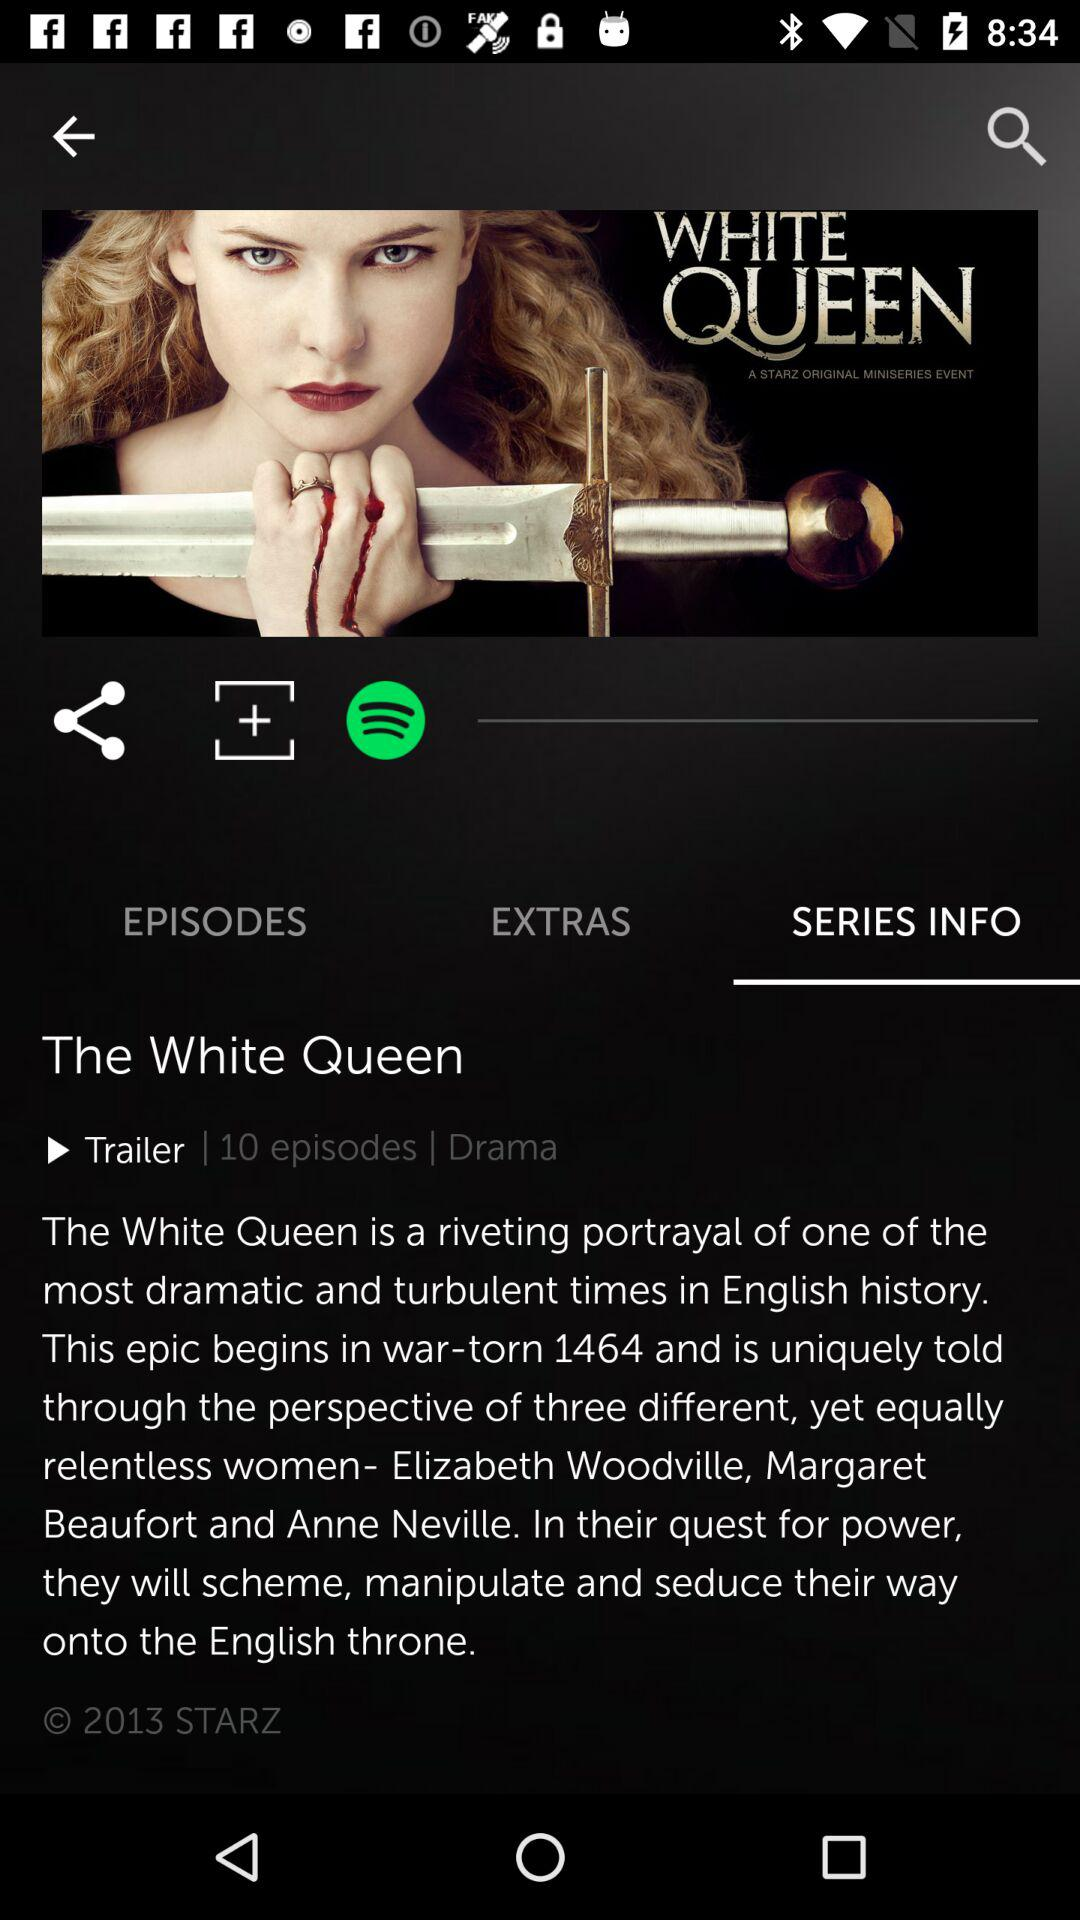How many episodes are there? There are 10 episodes. 